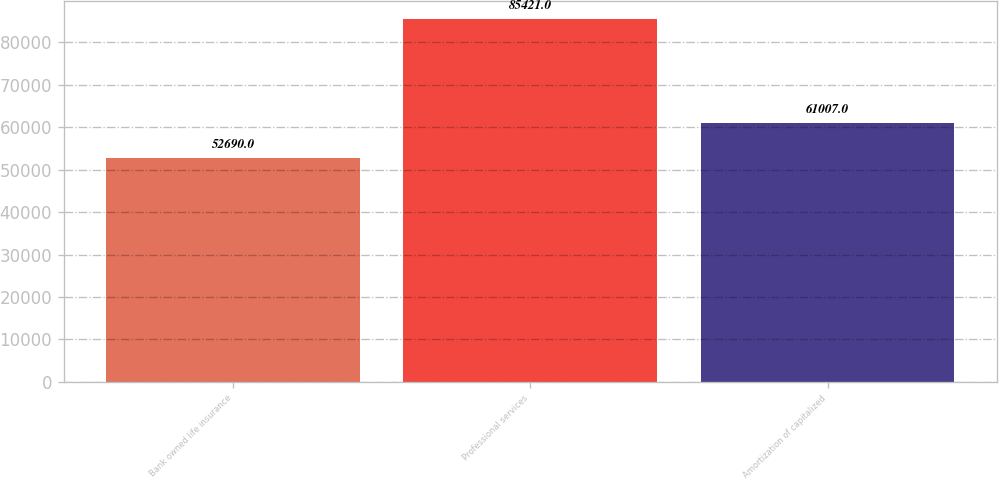Convert chart to OTSL. <chart><loc_0><loc_0><loc_500><loc_500><bar_chart><fcel>Bank owned life insurance<fcel>Professional services<fcel>Amortization of capitalized<nl><fcel>52690<fcel>85421<fcel>61007<nl></chart> 